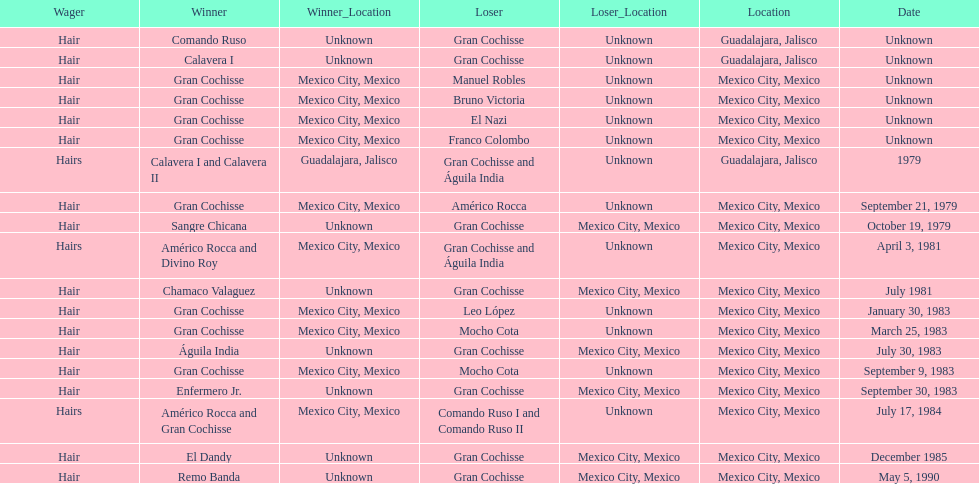How many times has the wager been hair? 16. 